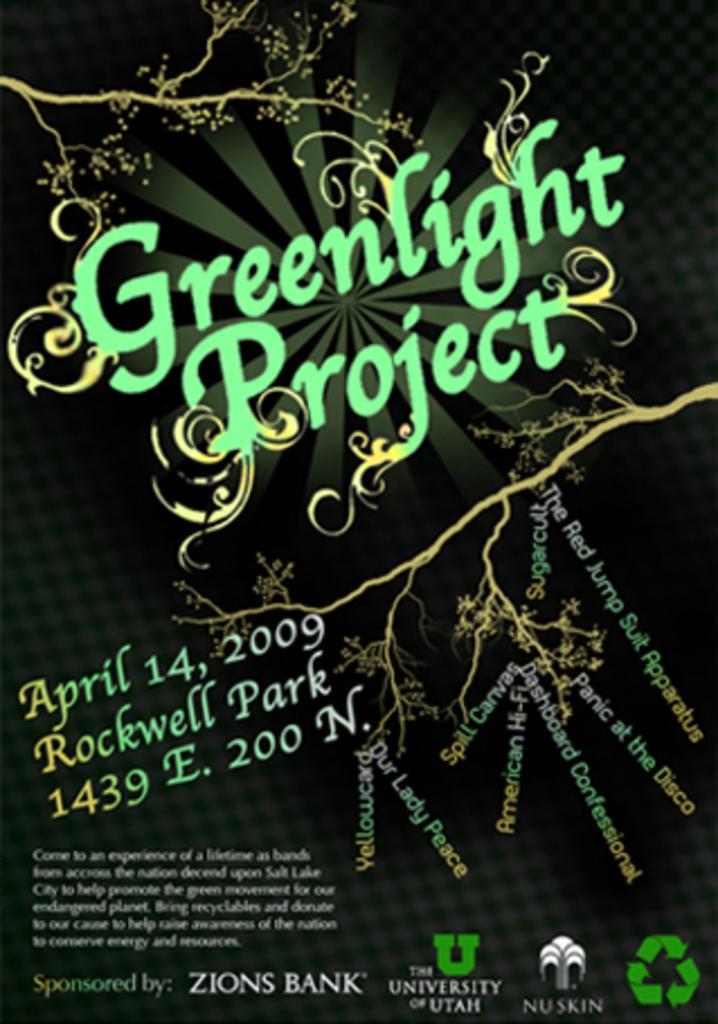Please provide a concise description of this image. In this picture I can see the poster. I can see the design and texts. 